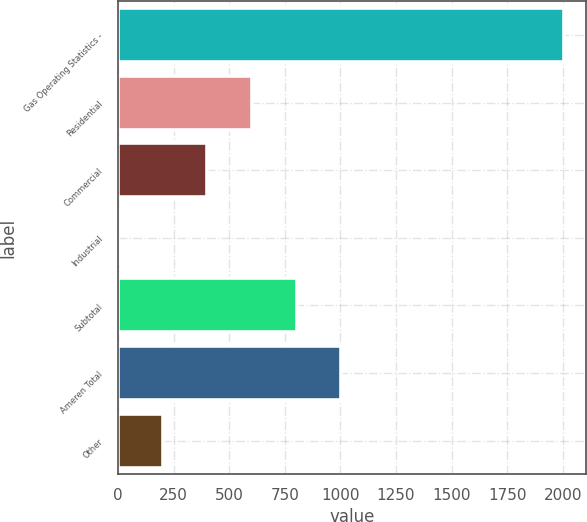<chart> <loc_0><loc_0><loc_500><loc_500><bar_chart><fcel>Gas Operating Statistics -<fcel>Residential<fcel>Commercial<fcel>Industrial<fcel>Subtotal<fcel>Ameren Total<fcel>Other<nl><fcel>2006<fcel>602.5<fcel>402<fcel>1<fcel>803<fcel>1003.5<fcel>201.5<nl></chart> 